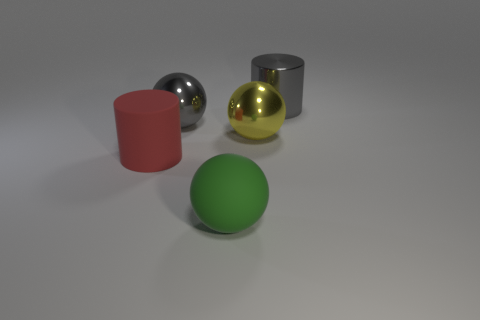Subtract all metallic balls. How many balls are left? 1 Add 5 large yellow metal balls. How many objects exist? 10 Subtract all balls. How many objects are left? 2 Subtract all large cylinders. Subtract all red rubber objects. How many objects are left? 2 Add 1 large green balls. How many large green balls are left? 2 Add 1 large metallic spheres. How many large metallic spheres exist? 3 Subtract 0 purple balls. How many objects are left? 5 